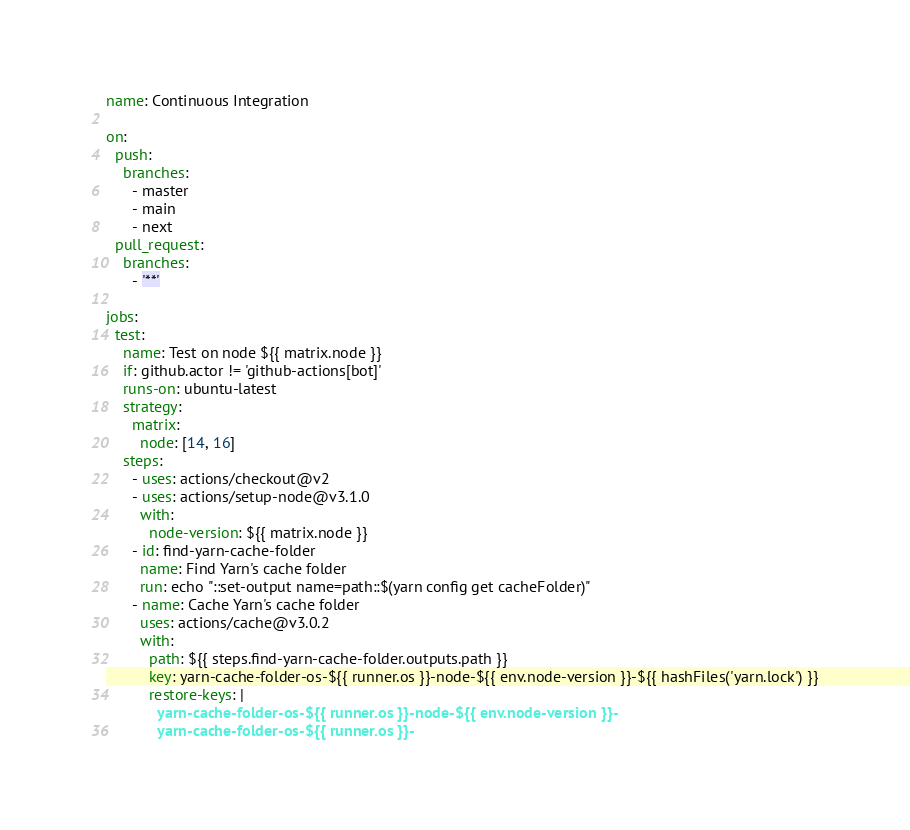Convert code to text. <code><loc_0><loc_0><loc_500><loc_500><_YAML_>name: Continuous Integration

on:
  push:
    branches:
      - master
      - main
      - next
  pull_request:
    branches:
      - '**'

jobs:
  test:
    name: Test on node ${{ matrix.node }}
    if: github.actor != 'github-actions[bot]'
    runs-on: ubuntu-latest
    strategy:
      matrix:
        node: [14, 16]
    steps:
      - uses: actions/checkout@v2
      - uses: actions/setup-node@v3.1.0
        with:
          node-version: ${{ matrix.node }}
      - id: find-yarn-cache-folder
        name: Find Yarn's cache folder
        run: echo "::set-output name=path::$(yarn config get cacheFolder)"
      - name: Cache Yarn's cache folder
        uses: actions/cache@v3.0.2
        with:
          path: ${{ steps.find-yarn-cache-folder.outputs.path }}
          key: yarn-cache-folder-os-${{ runner.os }}-node-${{ env.node-version }}-${{ hashFiles('yarn.lock') }}
          restore-keys: |
            yarn-cache-folder-os-${{ runner.os }}-node-${{ env.node-version }}-
            yarn-cache-folder-os-${{ runner.os }}-</code> 